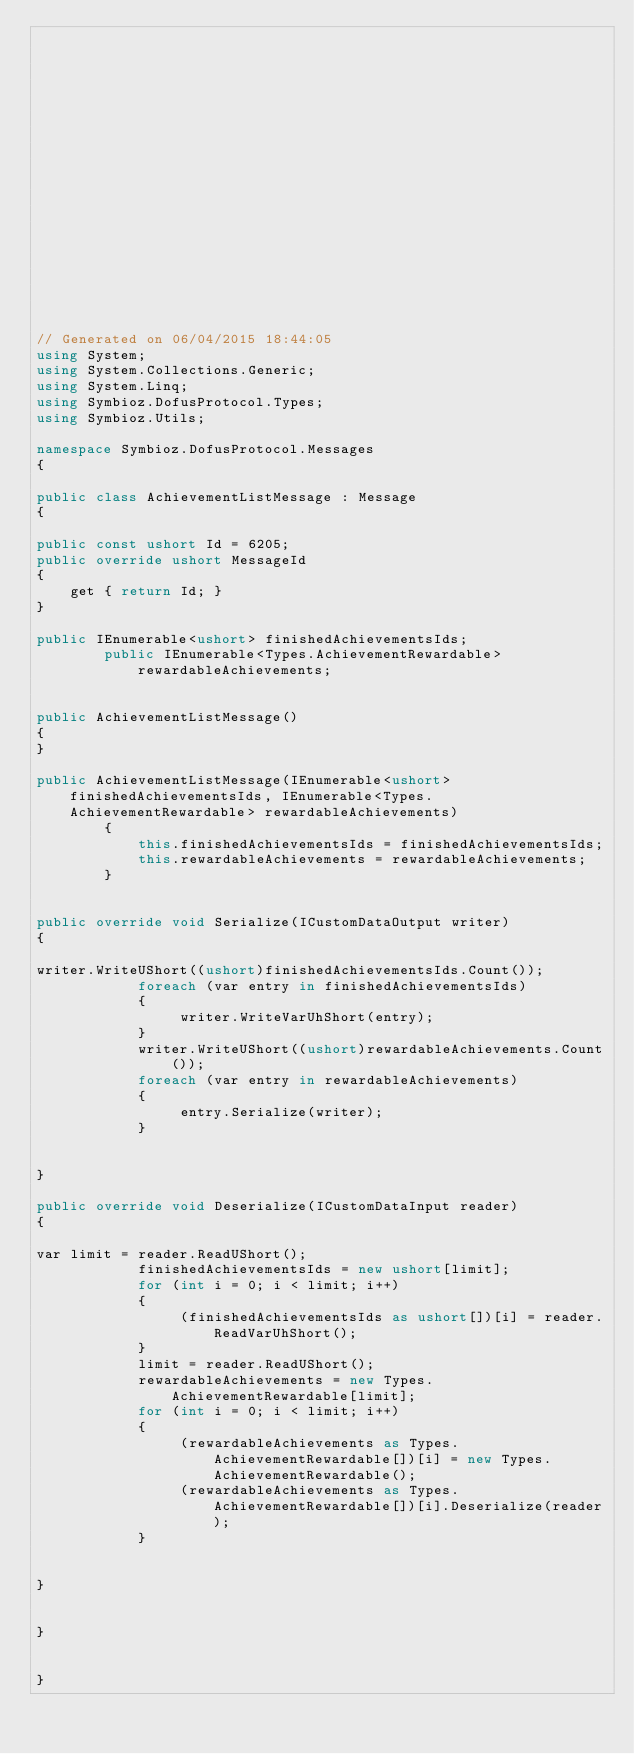Convert code to text. <code><loc_0><loc_0><loc_500><loc_500><_C#_>


















// Generated on 06/04/2015 18:44:05
using System;
using System.Collections.Generic;
using System.Linq;
using Symbioz.DofusProtocol.Types;
using Symbioz.Utils;

namespace Symbioz.DofusProtocol.Messages
{

public class AchievementListMessage : Message
{

public const ushort Id = 6205;
public override ushort MessageId
{
    get { return Id; }
}

public IEnumerable<ushort> finishedAchievementsIds;
        public IEnumerable<Types.AchievementRewardable> rewardableAchievements;
        

public AchievementListMessage()
{
}

public AchievementListMessage(IEnumerable<ushort> finishedAchievementsIds, IEnumerable<Types.AchievementRewardable> rewardableAchievements)
        {
            this.finishedAchievementsIds = finishedAchievementsIds;
            this.rewardableAchievements = rewardableAchievements;
        }
        

public override void Serialize(ICustomDataOutput writer)
{

writer.WriteUShort((ushort)finishedAchievementsIds.Count());
            foreach (var entry in finishedAchievementsIds)
            {
                 writer.WriteVarUhShort(entry);
            }
            writer.WriteUShort((ushort)rewardableAchievements.Count());
            foreach (var entry in rewardableAchievements)
            {
                 entry.Serialize(writer);
            }
            

}

public override void Deserialize(ICustomDataInput reader)
{

var limit = reader.ReadUShort();
            finishedAchievementsIds = new ushort[limit];
            for (int i = 0; i < limit; i++)
            {
                 (finishedAchievementsIds as ushort[])[i] = reader.ReadVarUhShort();
            }
            limit = reader.ReadUShort();
            rewardableAchievements = new Types.AchievementRewardable[limit];
            for (int i = 0; i < limit; i++)
            {
                 (rewardableAchievements as Types.AchievementRewardable[])[i] = new Types.AchievementRewardable();
                 (rewardableAchievements as Types.AchievementRewardable[])[i].Deserialize(reader);
            }
            

}


}


}</code> 